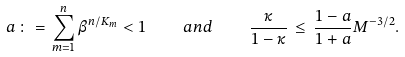Convert formula to latex. <formula><loc_0><loc_0><loc_500><loc_500>a \, \colon = \, \sum _ { m = 1 } ^ { n } \beta ^ { n / K _ { m } } < 1 \quad a n d \quad \frac { \kappa } { 1 - \kappa } \, \leq \, \frac { 1 - a } { 1 + a } M ^ { - 3 / 2 } .</formula> 